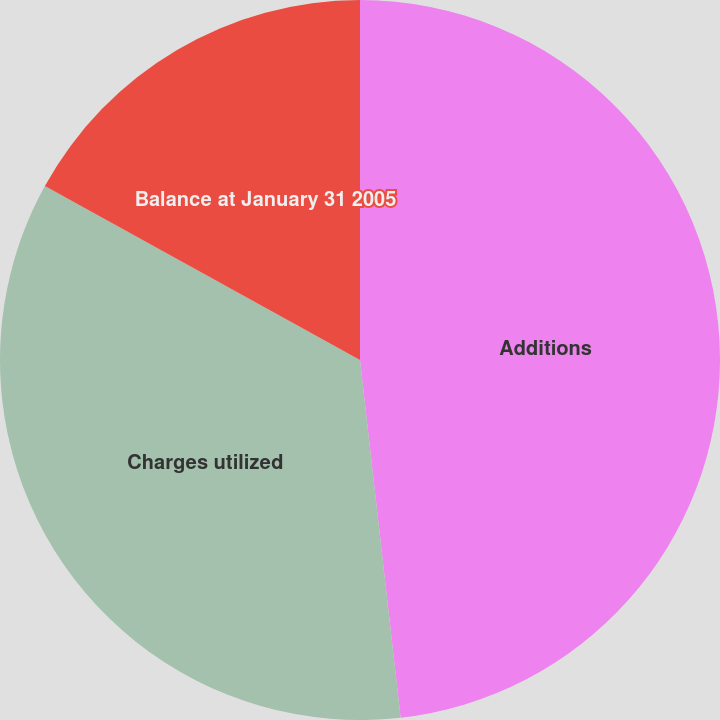Convert chart to OTSL. <chart><loc_0><loc_0><loc_500><loc_500><pie_chart><fcel>Additions<fcel>Charges utilized<fcel>Balance at January 31 2005<nl><fcel>48.2%<fcel>34.83%<fcel>16.97%<nl></chart> 